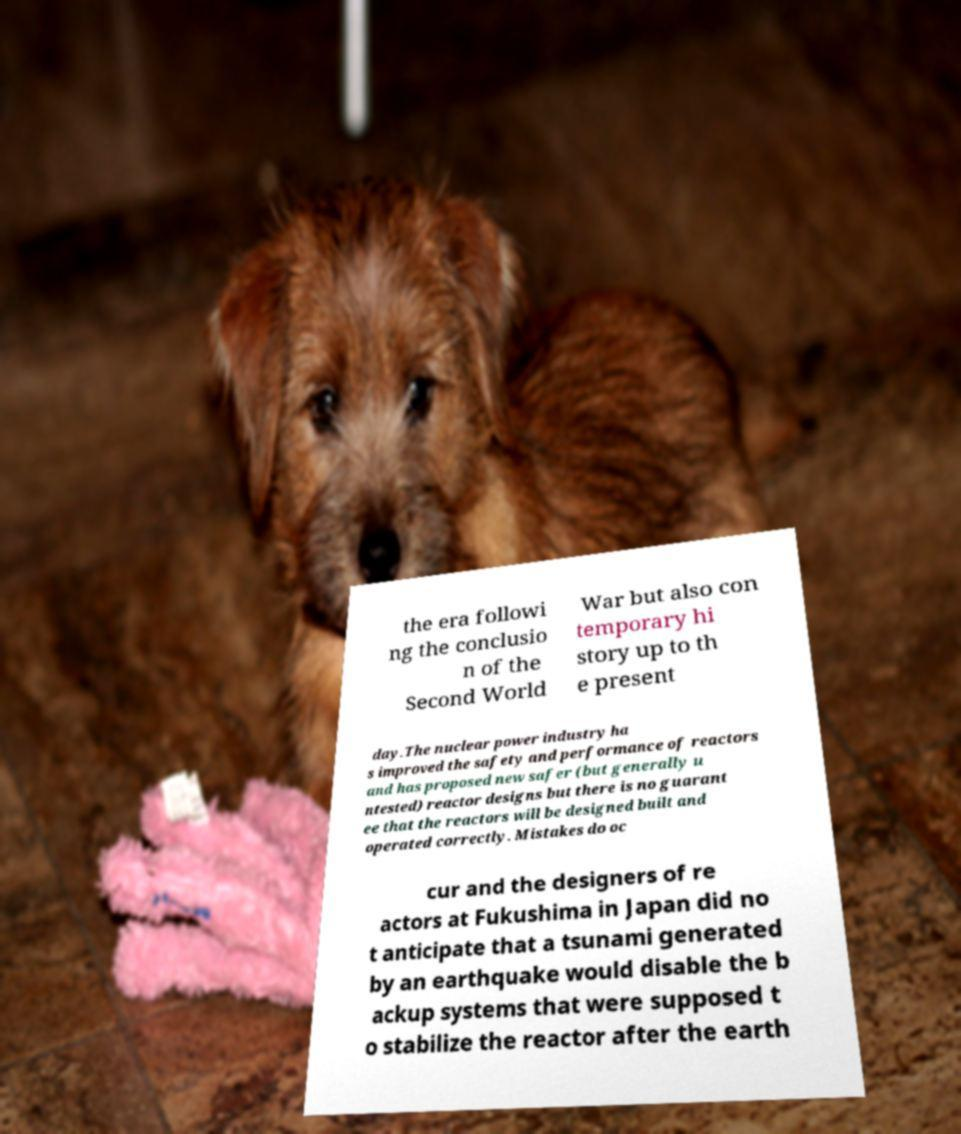Can you read and provide the text displayed in the image?This photo seems to have some interesting text. Can you extract and type it out for me? the era followi ng the conclusio n of the Second World War but also con temporary hi story up to th e present day.The nuclear power industry ha s improved the safety and performance of reactors and has proposed new safer (but generally u ntested) reactor designs but there is no guarant ee that the reactors will be designed built and operated correctly. Mistakes do oc cur and the designers of re actors at Fukushima in Japan did no t anticipate that a tsunami generated by an earthquake would disable the b ackup systems that were supposed t o stabilize the reactor after the earth 